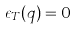<formula> <loc_0><loc_0><loc_500><loc_500>\epsilon _ { T } ( q ) = 0</formula> 